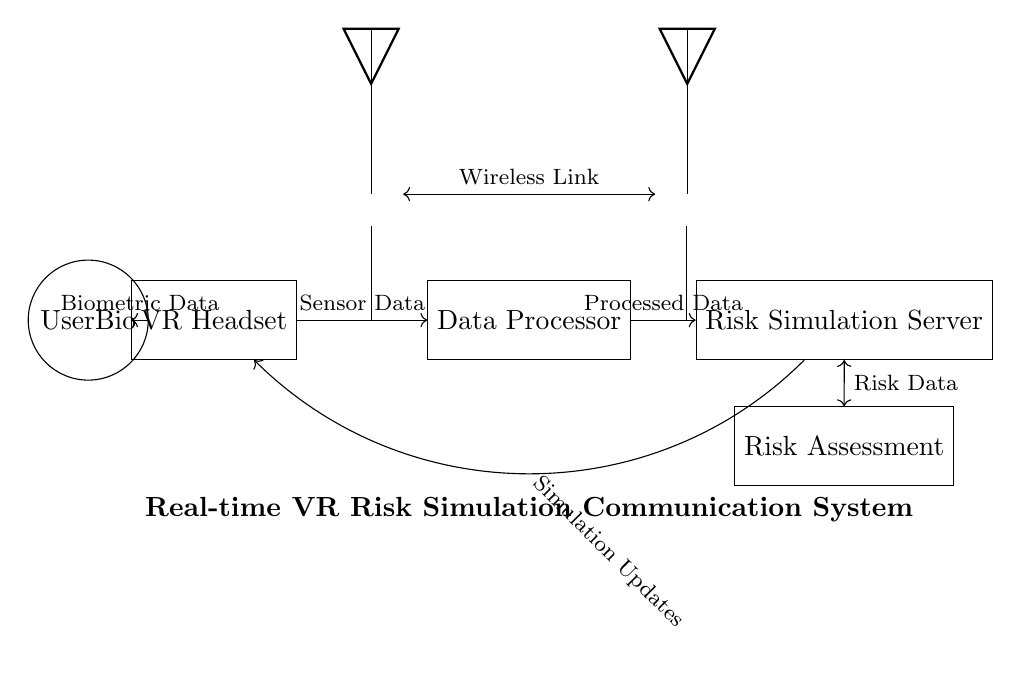What components are present in the circuit? The circuit contains a VR Headset, Data Processor, Risk Simulation Server, Wireless Transmitter, Wireless Receiver, User Biometrics, and Risk Assessment Module. These components are visually depicted in the circuit diagram.
Answer: VR Headset, Data Processor, Risk Simulation Server, Wireless Transmitter, Wireless Receiver, User Biometrics, Risk Assessment Module What type of data is sent from the VR Headset to the Data Processor? The circuit diagram indicates that "Sensor Data" is transferred from the VR Headset to the Data Processor, as labeled on the connection arrow.
Answer: Sensor Data What connects the Risk Simulation Server to the Risk Assessment Module? The connection is labeled "Risk Data," which shows that data is shared between these two components. The bidirectional arrow between the Risk Simulation Server and the Risk Assessment Module indicates this interaction.
Answer: Risk Data How are the Wireless Transmitter and Wireless Receiver connected? They are connected through a "Wireless Link," which is represented in the diagram by a double-headed arrow indicating a two-way communication pathway.
Answer: Wireless Link What type of data is fed from User Biometrics to the VR Headset? The diagram specifies that "Biometric Data" flows from User Biometrics to the VR Headset, as indicated by the connection labeled on the arrow in the circuit.
Answer: Biometric Data Why is there a feedback loop from the Risk Simulation Server to the VR Headset? The feedback loop labeled "Simulation Updates" indicates that the server sends updates back to the VR Headset based on simulated risk factors, which enhances the immersive experience and adjusts the VR environment in real time.
Answer: Simulation Updates What role does the Data Processor play in this communication system? The Data Processor's role is to process the "Sensor Data" received from the VR Headset before sending "Processed Data" to the Risk Simulation Server, therefore acting as an intermediary that manages the data flow and ensures the accuracy of information.
Answer: Intermediary 